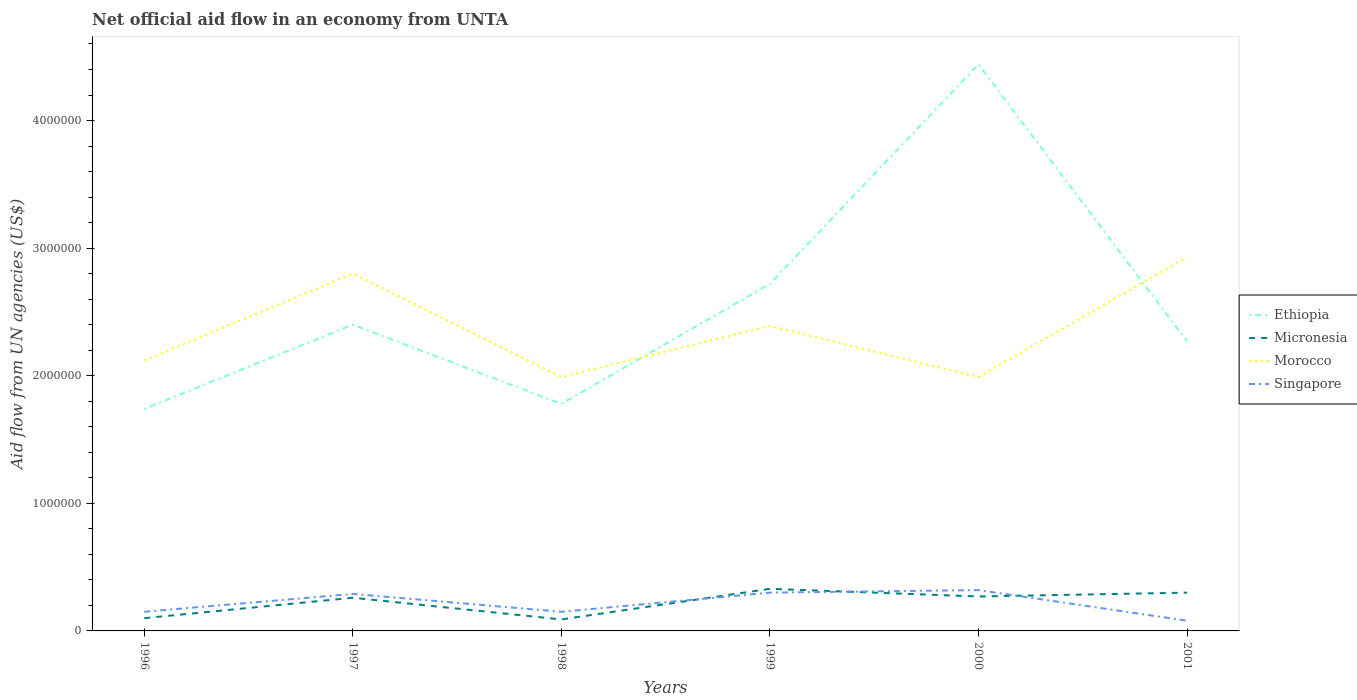How many different coloured lines are there?
Ensure brevity in your answer.  4. Does the line corresponding to Ethiopia intersect with the line corresponding to Morocco?
Your answer should be very brief. Yes. Is the number of lines equal to the number of legend labels?
Your answer should be very brief. Yes. Across all years, what is the maximum net official aid flow in Ethiopia?
Give a very brief answer. 1.74e+06. In which year was the net official aid flow in Micronesia maximum?
Provide a succinct answer. 1998. What is the difference between the highest and the second highest net official aid flow in Singapore?
Ensure brevity in your answer.  2.40e+05. What is the difference between the highest and the lowest net official aid flow in Singapore?
Your answer should be compact. 3. How many lines are there?
Your answer should be very brief. 4. Are the values on the major ticks of Y-axis written in scientific E-notation?
Provide a succinct answer. No. Does the graph contain any zero values?
Provide a short and direct response. No. Does the graph contain grids?
Make the answer very short. No. Where does the legend appear in the graph?
Your answer should be compact. Center right. How many legend labels are there?
Offer a terse response. 4. What is the title of the graph?
Your answer should be very brief. Net official aid flow in an economy from UNTA. What is the label or title of the Y-axis?
Provide a short and direct response. Aid flow from UN agencies (US$). What is the Aid flow from UN agencies (US$) of Ethiopia in 1996?
Give a very brief answer. 1.74e+06. What is the Aid flow from UN agencies (US$) in Micronesia in 1996?
Provide a succinct answer. 1.00e+05. What is the Aid flow from UN agencies (US$) in Morocco in 1996?
Make the answer very short. 2.12e+06. What is the Aid flow from UN agencies (US$) in Ethiopia in 1997?
Ensure brevity in your answer.  2.40e+06. What is the Aid flow from UN agencies (US$) in Morocco in 1997?
Your response must be concise. 2.80e+06. What is the Aid flow from UN agencies (US$) in Singapore in 1997?
Provide a succinct answer. 2.90e+05. What is the Aid flow from UN agencies (US$) of Ethiopia in 1998?
Give a very brief answer. 1.78e+06. What is the Aid flow from UN agencies (US$) in Micronesia in 1998?
Give a very brief answer. 9.00e+04. What is the Aid flow from UN agencies (US$) of Morocco in 1998?
Your answer should be compact. 1.99e+06. What is the Aid flow from UN agencies (US$) in Ethiopia in 1999?
Make the answer very short. 2.72e+06. What is the Aid flow from UN agencies (US$) of Morocco in 1999?
Keep it short and to the point. 2.39e+06. What is the Aid flow from UN agencies (US$) in Ethiopia in 2000?
Provide a short and direct response. 4.44e+06. What is the Aid flow from UN agencies (US$) in Micronesia in 2000?
Provide a short and direct response. 2.70e+05. What is the Aid flow from UN agencies (US$) of Morocco in 2000?
Offer a terse response. 1.99e+06. What is the Aid flow from UN agencies (US$) of Singapore in 2000?
Your response must be concise. 3.20e+05. What is the Aid flow from UN agencies (US$) of Ethiopia in 2001?
Offer a terse response. 2.27e+06. What is the Aid flow from UN agencies (US$) in Morocco in 2001?
Provide a succinct answer. 2.93e+06. Across all years, what is the maximum Aid flow from UN agencies (US$) in Ethiopia?
Make the answer very short. 4.44e+06. Across all years, what is the maximum Aid flow from UN agencies (US$) in Morocco?
Ensure brevity in your answer.  2.93e+06. Across all years, what is the maximum Aid flow from UN agencies (US$) of Singapore?
Offer a very short reply. 3.20e+05. Across all years, what is the minimum Aid flow from UN agencies (US$) of Ethiopia?
Your answer should be very brief. 1.74e+06. Across all years, what is the minimum Aid flow from UN agencies (US$) in Micronesia?
Provide a short and direct response. 9.00e+04. Across all years, what is the minimum Aid flow from UN agencies (US$) in Morocco?
Offer a terse response. 1.99e+06. What is the total Aid flow from UN agencies (US$) in Ethiopia in the graph?
Offer a very short reply. 1.54e+07. What is the total Aid flow from UN agencies (US$) of Micronesia in the graph?
Keep it short and to the point. 1.35e+06. What is the total Aid flow from UN agencies (US$) of Morocco in the graph?
Give a very brief answer. 1.42e+07. What is the total Aid flow from UN agencies (US$) in Singapore in the graph?
Your answer should be compact. 1.29e+06. What is the difference between the Aid flow from UN agencies (US$) in Ethiopia in 1996 and that in 1997?
Ensure brevity in your answer.  -6.60e+05. What is the difference between the Aid flow from UN agencies (US$) of Micronesia in 1996 and that in 1997?
Give a very brief answer. -1.60e+05. What is the difference between the Aid flow from UN agencies (US$) of Morocco in 1996 and that in 1997?
Offer a very short reply. -6.80e+05. What is the difference between the Aid flow from UN agencies (US$) in Morocco in 1996 and that in 1998?
Your answer should be compact. 1.30e+05. What is the difference between the Aid flow from UN agencies (US$) in Ethiopia in 1996 and that in 1999?
Your answer should be very brief. -9.80e+05. What is the difference between the Aid flow from UN agencies (US$) of Morocco in 1996 and that in 1999?
Keep it short and to the point. -2.70e+05. What is the difference between the Aid flow from UN agencies (US$) in Singapore in 1996 and that in 1999?
Provide a succinct answer. -1.50e+05. What is the difference between the Aid flow from UN agencies (US$) in Ethiopia in 1996 and that in 2000?
Give a very brief answer. -2.70e+06. What is the difference between the Aid flow from UN agencies (US$) in Micronesia in 1996 and that in 2000?
Your response must be concise. -1.70e+05. What is the difference between the Aid flow from UN agencies (US$) in Morocco in 1996 and that in 2000?
Provide a succinct answer. 1.30e+05. What is the difference between the Aid flow from UN agencies (US$) of Ethiopia in 1996 and that in 2001?
Provide a short and direct response. -5.30e+05. What is the difference between the Aid flow from UN agencies (US$) of Micronesia in 1996 and that in 2001?
Ensure brevity in your answer.  -2.00e+05. What is the difference between the Aid flow from UN agencies (US$) of Morocco in 1996 and that in 2001?
Offer a very short reply. -8.10e+05. What is the difference between the Aid flow from UN agencies (US$) in Singapore in 1996 and that in 2001?
Make the answer very short. 7.00e+04. What is the difference between the Aid flow from UN agencies (US$) in Ethiopia in 1997 and that in 1998?
Your answer should be compact. 6.20e+05. What is the difference between the Aid flow from UN agencies (US$) of Morocco in 1997 and that in 1998?
Offer a very short reply. 8.10e+05. What is the difference between the Aid flow from UN agencies (US$) in Ethiopia in 1997 and that in 1999?
Make the answer very short. -3.20e+05. What is the difference between the Aid flow from UN agencies (US$) in Morocco in 1997 and that in 1999?
Your answer should be compact. 4.10e+05. What is the difference between the Aid flow from UN agencies (US$) of Singapore in 1997 and that in 1999?
Keep it short and to the point. -10000. What is the difference between the Aid flow from UN agencies (US$) of Ethiopia in 1997 and that in 2000?
Your answer should be very brief. -2.04e+06. What is the difference between the Aid flow from UN agencies (US$) of Morocco in 1997 and that in 2000?
Give a very brief answer. 8.10e+05. What is the difference between the Aid flow from UN agencies (US$) of Morocco in 1997 and that in 2001?
Provide a succinct answer. -1.30e+05. What is the difference between the Aid flow from UN agencies (US$) of Ethiopia in 1998 and that in 1999?
Keep it short and to the point. -9.40e+05. What is the difference between the Aid flow from UN agencies (US$) of Micronesia in 1998 and that in 1999?
Provide a succinct answer. -2.40e+05. What is the difference between the Aid flow from UN agencies (US$) in Morocco in 1998 and that in 1999?
Make the answer very short. -4.00e+05. What is the difference between the Aid flow from UN agencies (US$) in Singapore in 1998 and that in 1999?
Your answer should be very brief. -1.50e+05. What is the difference between the Aid flow from UN agencies (US$) in Ethiopia in 1998 and that in 2000?
Keep it short and to the point. -2.66e+06. What is the difference between the Aid flow from UN agencies (US$) in Ethiopia in 1998 and that in 2001?
Keep it short and to the point. -4.90e+05. What is the difference between the Aid flow from UN agencies (US$) in Micronesia in 1998 and that in 2001?
Offer a terse response. -2.10e+05. What is the difference between the Aid flow from UN agencies (US$) of Morocco in 1998 and that in 2001?
Provide a succinct answer. -9.40e+05. What is the difference between the Aid flow from UN agencies (US$) of Singapore in 1998 and that in 2001?
Offer a very short reply. 7.00e+04. What is the difference between the Aid flow from UN agencies (US$) in Ethiopia in 1999 and that in 2000?
Offer a very short reply. -1.72e+06. What is the difference between the Aid flow from UN agencies (US$) in Morocco in 1999 and that in 2000?
Provide a short and direct response. 4.00e+05. What is the difference between the Aid flow from UN agencies (US$) in Ethiopia in 1999 and that in 2001?
Your answer should be compact. 4.50e+05. What is the difference between the Aid flow from UN agencies (US$) of Morocco in 1999 and that in 2001?
Offer a very short reply. -5.40e+05. What is the difference between the Aid flow from UN agencies (US$) in Ethiopia in 2000 and that in 2001?
Your response must be concise. 2.17e+06. What is the difference between the Aid flow from UN agencies (US$) in Morocco in 2000 and that in 2001?
Offer a very short reply. -9.40e+05. What is the difference between the Aid flow from UN agencies (US$) of Singapore in 2000 and that in 2001?
Keep it short and to the point. 2.40e+05. What is the difference between the Aid flow from UN agencies (US$) of Ethiopia in 1996 and the Aid flow from UN agencies (US$) of Micronesia in 1997?
Give a very brief answer. 1.48e+06. What is the difference between the Aid flow from UN agencies (US$) of Ethiopia in 1996 and the Aid flow from UN agencies (US$) of Morocco in 1997?
Your response must be concise. -1.06e+06. What is the difference between the Aid flow from UN agencies (US$) in Ethiopia in 1996 and the Aid flow from UN agencies (US$) in Singapore in 1997?
Offer a terse response. 1.45e+06. What is the difference between the Aid flow from UN agencies (US$) in Micronesia in 1996 and the Aid flow from UN agencies (US$) in Morocco in 1997?
Keep it short and to the point. -2.70e+06. What is the difference between the Aid flow from UN agencies (US$) in Micronesia in 1996 and the Aid flow from UN agencies (US$) in Singapore in 1997?
Provide a succinct answer. -1.90e+05. What is the difference between the Aid flow from UN agencies (US$) in Morocco in 1996 and the Aid flow from UN agencies (US$) in Singapore in 1997?
Ensure brevity in your answer.  1.83e+06. What is the difference between the Aid flow from UN agencies (US$) in Ethiopia in 1996 and the Aid flow from UN agencies (US$) in Micronesia in 1998?
Give a very brief answer. 1.65e+06. What is the difference between the Aid flow from UN agencies (US$) in Ethiopia in 1996 and the Aid flow from UN agencies (US$) in Singapore in 1998?
Keep it short and to the point. 1.59e+06. What is the difference between the Aid flow from UN agencies (US$) of Micronesia in 1996 and the Aid flow from UN agencies (US$) of Morocco in 1998?
Provide a succinct answer. -1.89e+06. What is the difference between the Aid flow from UN agencies (US$) in Morocco in 1996 and the Aid flow from UN agencies (US$) in Singapore in 1998?
Provide a short and direct response. 1.97e+06. What is the difference between the Aid flow from UN agencies (US$) of Ethiopia in 1996 and the Aid flow from UN agencies (US$) of Micronesia in 1999?
Give a very brief answer. 1.41e+06. What is the difference between the Aid flow from UN agencies (US$) in Ethiopia in 1996 and the Aid flow from UN agencies (US$) in Morocco in 1999?
Keep it short and to the point. -6.50e+05. What is the difference between the Aid flow from UN agencies (US$) of Ethiopia in 1996 and the Aid flow from UN agencies (US$) of Singapore in 1999?
Offer a terse response. 1.44e+06. What is the difference between the Aid flow from UN agencies (US$) of Micronesia in 1996 and the Aid flow from UN agencies (US$) of Morocco in 1999?
Give a very brief answer. -2.29e+06. What is the difference between the Aid flow from UN agencies (US$) of Micronesia in 1996 and the Aid flow from UN agencies (US$) of Singapore in 1999?
Keep it short and to the point. -2.00e+05. What is the difference between the Aid flow from UN agencies (US$) of Morocco in 1996 and the Aid flow from UN agencies (US$) of Singapore in 1999?
Keep it short and to the point. 1.82e+06. What is the difference between the Aid flow from UN agencies (US$) of Ethiopia in 1996 and the Aid flow from UN agencies (US$) of Micronesia in 2000?
Your response must be concise. 1.47e+06. What is the difference between the Aid flow from UN agencies (US$) in Ethiopia in 1996 and the Aid flow from UN agencies (US$) in Morocco in 2000?
Offer a very short reply. -2.50e+05. What is the difference between the Aid flow from UN agencies (US$) of Ethiopia in 1996 and the Aid flow from UN agencies (US$) of Singapore in 2000?
Your answer should be very brief. 1.42e+06. What is the difference between the Aid flow from UN agencies (US$) of Micronesia in 1996 and the Aid flow from UN agencies (US$) of Morocco in 2000?
Give a very brief answer. -1.89e+06. What is the difference between the Aid flow from UN agencies (US$) in Micronesia in 1996 and the Aid flow from UN agencies (US$) in Singapore in 2000?
Ensure brevity in your answer.  -2.20e+05. What is the difference between the Aid flow from UN agencies (US$) in Morocco in 1996 and the Aid flow from UN agencies (US$) in Singapore in 2000?
Give a very brief answer. 1.80e+06. What is the difference between the Aid flow from UN agencies (US$) of Ethiopia in 1996 and the Aid flow from UN agencies (US$) of Micronesia in 2001?
Offer a very short reply. 1.44e+06. What is the difference between the Aid flow from UN agencies (US$) of Ethiopia in 1996 and the Aid flow from UN agencies (US$) of Morocco in 2001?
Keep it short and to the point. -1.19e+06. What is the difference between the Aid flow from UN agencies (US$) in Ethiopia in 1996 and the Aid flow from UN agencies (US$) in Singapore in 2001?
Offer a terse response. 1.66e+06. What is the difference between the Aid flow from UN agencies (US$) in Micronesia in 1996 and the Aid flow from UN agencies (US$) in Morocco in 2001?
Your answer should be very brief. -2.83e+06. What is the difference between the Aid flow from UN agencies (US$) in Morocco in 1996 and the Aid flow from UN agencies (US$) in Singapore in 2001?
Your response must be concise. 2.04e+06. What is the difference between the Aid flow from UN agencies (US$) in Ethiopia in 1997 and the Aid flow from UN agencies (US$) in Micronesia in 1998?
Your answer should be compact. 2.31e+06. What is the difference between the Aid flow from UN agencies (US$) of Ethiopia in 1997 and the Aid flow from UN agencies (US$) of Singapore in 1998?
Keep it short and to the point. 2.25e+06. What is the difference between the Aid flow from UN agencies (US$) of Micronesia in 1997 and the Aid flow from UN agencies (US$) of Morocco in 1998?
Offer a terse response. -1.73e+06. What is the difference between the Aid flow from UN agencies (US$) in Micronesia in 1997 and the Aid flow from UN agencies (US$) in Singapore in 1998?
Your response must be concise. 1.10e+05. What is the difference between the Aid flow from UN agencies (US$) in Morocco in 1997 and the Aid flow from UN agencies (US$) in Singapore in 1998?
Your response must be concise. 2.65e+06. What is the difference between the Aid flow from UN agencies (US$) in Ethiopia in 1997 and the Aid flow from UN agencies (US$) in Micronesia in 1999?
Your response must be concise. 2.07e+06. What is the difference between the Aid flow from UN agencies (US$) in Ethiopia in 1997 and the Aid flow from UN agencies (US$) in Morocco in 1999?
Provide a short and direct response. 10000. What is the difference between the Aid flow from UN agencies (US$) of Ethiopia in 1997 and the Aid flow from UN agencies (US$) of Singapore in 1999?
Give a very brief answer. 2.10e+06. What is the difference between the Aid flow from UN agencies (US$) of Micronesia in 1997 and the Aid flow from UN agencies (US$) of Morocco in 1999?
Offer a very short reply. -2.13e+06. What is the difference between the Aid flow from UN agencies (US$) of Micronesia in 1997 and the Aid flow from UN agencies (US$) of Singapore in 1999?
Provide a short and direct response. -4.00e+04. What is the difference between the Aid flow from UN agencies (US$) of Morocco in 1997 and the Aid flow from UN agencies (US$) of Singapore in 1999?
Keep it short and to the point. 2.50e+06. What is the difference between the Aid flow from UN agencies (US$) in Ethiopia in 1997 and the Aid flow from UN agencies (US$) in Micronesia in 2000?
Offer a very short reply. 2.13e+06. What is the difference between the Aid flow from UN agencies (US$) of Ethiopia in 1997 and the Aid flow from UN agencies (US$) of Singapore in 2000?
Provide a short and direct response. 2.08e+06. What is the difference between the Aid flow from UN agencies (US$) in Micronesia in 1997 and the Aid flow from UN agencies (US$) in Morocco in 2000?
Offer a very short reply. -1.73e+06. What is the difference between the Aid flow from UN agencies (US$) in Morocco in 1997 and the Aid flow from UN agencies (US$) in Singapore in 2000?
Provide a short and direct response. 2.48e+06. What is the difference between the Aid flow from UN agencies (US$) in Ethiopia in 1997 and the Aid flow from UN agencies (US$) in Micronesia in 2001?
Your response must be concise. 2.10e+06. What is the difference between the Aid flow from UN agencies (US$) in Ethiopia in 1997 and the Aid flow from UN agencies (US$) in Morocco in 2001?
Your response must be concise. -5.30e+05. What is the difference between the Aid flow from UN agencies (US$) in Ethiopia in 1997 and the Aid flow from UN agencies (US$) in Singapore in 2001?
Your answer should be compact. 2.32e+06. What is the difference between the Aid flow from UN agencies (US$) of Micronesia in 1997 and the Aid flow from UN agencies (US$) of Morocco in 2001?
Keep it short and to the point. -2.67e+06. What is the difference between the Aid flow from UN agencies (US$) of Micronesia in 1997 and the Aid flow from UN agencies (US$) of Singapore in 2001?
Your answer should be compact. 1.80e+05. What is the difference between the Aid flow from UN agencies (US$) of Morocco in 1997 and the Aid flow from UN agencies (US$) of Singapore in 2001?
Your response must be concise. 2.72e+06. What is the difference between the Aid flow from UN agencies (US$) of Ethiopia in 1998 and the Aid flow from UN agencies (US$) of Micronesia in 1999?
Provide a short and direct response. 1.45e+06. What is the difference between the Aid flow from UN agencies (US$) of Ethiopia in 1998 and the Aid flow from UN agencies (US$) of Morocco in 1999?
Ensure brevity in your answer.  -6.10e+05. What is the difference between the Aid flow from UN agencies (US$) in Ethiopia in 1998 and the Aid flow from UN agencies (US$) in Singapore in 1999?
Provide a succinct answer. 1.48e+06. What is the difference between the Aid flow from UN agencies (US$) of Micronesia in 1998 and the Aid flow from UN agencies (US$) of Morocco in 1999?
Offer a very short reply. -2.30e+06. What is the difference between the Aid flow from UN agencies (US$) in Morocco in 1998 and the Aid flow from UN agencies (US$) in Singapore in 1999?
Your answer should be very brief. 1.69e+06. What is the difference between the Aid flow from UN agencies (US$) of Ethiopia in 1998 and the Aid flow from UN agencies (US$) of Micronesia in 2000?
Give a very brief answer. 1.51e+06. What is the difference between the Aid flow from UN agencies (US$) in Ethiopia in 1998 and the Aid flow from UN agencies (US$) in Singapore in 2000?
Offer a terse response. 1.46e+06. What is the difference between the Aid flow from UN agencies (US$) of Micronesia in 1998 and the Aid flow from UN agencies (US$) of Morocco in 2000?
Your response must be concise. -1.90e+06. What is the difference between the Aid flow from UN agencies (US$) of Micronesia in 1998 and the Aid flow from UN agencies (US$) of Singapore in 2000?
Offer a very short reply. -2.30e+05. What is the difference between the Aid flow from UN agencies (US$) of Morocco in 1998 and the Aid flow from UN agencies (US$) of Singapore in 2000?
Ensure brevity in your answer.  1.67e+06. What is the difference between the Aid flow from UN agencies (US$) in Ethiopia in 1998 and the Aid flow from UN agencies (US$) in Micronesia in 2001?
Offer a very short reply. 1.48e+06. What is the difference between the Aid flow from UN agencies (US$) in Ethiopia in 1998 and the Aid flow from UN agencies (US$) in Morocco in 2001?
Give a very brief answer. -1.15e+06. What is the difference between the Aid flow from UN agencies (US$) of Ethiopia in 1998 and the Aid flow from UN agencies (US$) of Singapore in 2001?
Give a very brief answer. 1.70e+06. What is the difference between the Aid flow from UN agencies (US$) in Micronesia in 1998 and the Aid flow from UN agencies (US$) in Morocco in 2001?
Your answer should be very brief. -2.84e+06. What is the difference between the Aid flow from UN agencies (US$) of Morocco in 1998 and the Aid flow from UN agencies (US$) of Singapore in 2001?
Offer a terse response. 1.91e+06. What is the difference between the Aid flow from UN agencies (US$) in Ethiopia in 1999 and the Aid flow from UN agencies (US$) in Micronesia in 2000?
Keep it short and to the point. 2.45e+06. What is the difference between the Aid flow from UN agencies (US$) in Ethiopia in 1999 and the Aid flow from UN agencies (US$) in Morocco in 2000?
Your answer should be very brief. 7.30e+05. What is the difference between the Aid flow from UN agencies (US$) in Ethiopia in 1999 and the Aid flow from UN agencies (US$) in Singapore in 2000?
Your answer should be very brief. 2.40e+06. What is the difference between the Aid flow from UN agencies (US$) in Micronesia in 1999 and the Aid flow from UN agencies (US$) in Morocco in 2000?
Your answer should be compact. -1.66e+06. What is the difference between the Aid flow from UN agencies (US$) in Micronesia in 1999 and the Aid flow from UN agencies (US$) in Singapore in 2000?
Ensure brevity in your answer.  10000. What is the difference between the Aid flow from UN agencies (US$) in Morocco in 1999 and the Aid flow from UN agencies (US$) in Singapore in 2000?
Your answer should be compact. 2.07e+06. What is the difference between the Aid flow from UN agencies (US$) of Ethiopia in 1999 and the Aid flow from UN agencies (US$) of Micronesia in 2001?
Keep it short and to the point. 2.42e+06. What is the difference between the Aid flow from UN agencies (US$) of Ethiopia in 1999 and the Aid flow from UN agencies (US$) of Singapore in 2001?
Ensure brevity in your answer.  2.64e+06. What is the difference between the Aid flow from UN agencies (US$) of Micronesia in 1999 and the Aid flow from UN agencies (US$) of Morocco in 2001?
Offer a very short reply. -2.60e+06. What is the difference between the Aid flow from UN agencies (US$) in Morocco in 1999 and the Aid flow from UN agencies (US$) in Singapore in 2001?
Keep it short and to the point. 2.31e+06. What is the difference between the Aid flow from UN agencies (US$) in Ethiopia in 2000 and the Aid flow from UN agencies (US$) in Micronesia in 2001?
Ensure brevity in your answer.  4.14e+06. What is the difference between the Aid flow from UN agencies (US$) in Ethiopia in 2000 and the Aid flow from UN agencies (US$) in Morocco in 2001?
Provide a short and direct response. 1.51e+06. What is the difference between the Aid flow from UN agencies (US$) of Ethiopia in 2000 and the Aid flow from UN agencies (US$) of Singapore in 2001?
Offer a very short reply. 4.36e+06. What is the difference between the Aid flow from UN agencies (US$) in Micronesia in 2000 and the Aid flow from UN agencies (US$) in Morocco in 2001?
Provide a succinct answer. -2.66e+06. What is the difference between the Aid flow from UN agencies (US$) in Micronesia in 2000 and the Aid flow from UN agencies (US$) in Singapore in 2001?
Provide a succinct answer. 1.90e+05. What is the difference between the Aid flow from UN agencies (US$) in Morocco in 2000 and the Aid flow from UN agencies (US$) in Singapore in 2001?
Provide a succinct answer. 1.91e+06. What is the average Aid flow from UN agencies (US$) of Ethiopia per year?
Your answer should be compact. 2.56e+06. What is the average Aid flow from UN agencies (US$) of Micronesia per year?
Make the answer very short. 2.25e+05. What is the average Aid flow from UN agencies (US$) of Morocco per year?
Your answer should be compact. 2.37e+06. What is the average Aid flow from UN agencies (US$) of Singapore per year?
Keep it short and to the point. 2.15e+05. In the year 1996, what is the difference between the Aid flow from UN agencies (US$) of Ethiopia and Aid flow from UN agencies (US$) of Micronesia?
Provide a short and direct response. 1.64e+06. In the year 1996, what is the difference between the Aid flow from UN agencies (US$) of Ethiopia and Aid flow from UN agencies (US$) of Morocco?
Offer a very short reply. -3.80e+05. In the year 1996, what is the difference between the Aid flow from UN agencies (US$) in Ethiopia and Aid flow from UN agencies (US$) in Singapore?
Ensure brevity in your answer.  1.59e+06. In the year 1996, what is the difference between the Aid flow from UN agencies (US$) in Micronesia and Aid flow from UN agencies (US$) in Morocco?
Provide a short and direct response. -2.02e+06. In the year 1996, what is the difference between the Aid flow from UN agencies (US$) in Morocco and Aid flow from UN agencies (US$) in Singapore?
Your answer should be compact. 1.97e+06. In the year 1997, what is the difference between the Aid flow from UN agencies (US$) of Ethiopia and Aid flow from UN agencies (US$) of Micronesia?
Provide a short and direct response. 2.14e+06. In the year 1997, what is the difference between the Aid flow from UN agencies (US$) of Ethiopia and Aid flow from UN agencies (US$) of Morocco?
Make the answer very short. -4.00e+05. In the year 1997, what is the difference between the Aid flow from UN agencies (US$) in Ethiopia and Aid flow from UN agencies (US$) in Singapore?
Give a very brief answer. 2.11e+06. In the year 1997, what is the difference between the Aid flow from UN agencies (US$) in Micronesia and Aid flow from UN agencies (US$) in Morocco?
Keep it short and to the point. -2.54e+06. In the year 1997, what is the difference between the Aid flow from UN agencies (US$) of Morocco and Aid flow from UN agencies (US$) of Singapore?
Provide a short and direct response. 2.51e+06. In the year 1998, what is the difference between the Aid flow from UN agencies (US$) of Ethiopia and Aid flow from UN agencies (US$) of Micronesia?
Ensure brevity in your answer.  1.69e+06. In the year 1998, what is the difference between the Aid flow from UN agencies (US$) in Ethiopia and Aid flow from UN agencies (US$) in Morocco?
Provide a succinct answer. -2.10e+05. In the year 1998, what is the difference between the Aid flow from UN agencies (US$) of Ethiopia and Aid flow from UN agencies (US$) of Singapore?
Your answer should be compact. 1.63e+06. In the year 1998, what is the difference between the Aid flow from UN agencies (US$) of Micronesia and Aid flow from UN agencies (US$) of Morocco?
Offer a terse response. -1.90e+06. In the year 1998, what is the difference between the Aid flow from UN agencies (US$) in Morocco and Aid flow from UN agencies (US$) in Singapore?
Ensure brevity in your answer.  1.84e+06. In the year 1999, what is the difference between the Aid flow from UN agencies (US$) in Ethiopia and Aid flow from UN agencies (US$) in Micronesia?
Make the answer very short. 2.39e+06. In the year 1999, what is the difference between the Aid flow from UN agencies (US$) in Ethiopia and Aid flow from UN agencies (US$) in Singapore?
Provide a succinct answer. 2.42e+06. In the year 1999, what is the difference between the Aid flow from UN agencies (US$) in Micronesia and Aid flow from UN agencies (US$) in Morocco?
Keep it short and to the point. -2.06e+06. In the year 1999, what is the difference between the Aid flow from UN agencies (US$) in Micronesia and Aid flow from UN agencies (US$) in Singapore?
Offer a terse response. 3.00e+04. In the year 1999, what is the difference between the Aid flow from UN agencies (US$) in Morocco and Aid flow from UN agencies (US$) in Singapore?
Your answer should be compact. 2.09e+06. In the year 2000, what is the difference between the Aid flow from UN agencies (US$) of Ethiopia and Aid flow from UN agencies (US$) of Micronesia?
Offer a terse response. 4.17e+06. In the year 2000, what is the difference between the Aid flow from UN agencies (US$) in Ethiopia and Aid flow from UN agencies (US$) in Morocco?
Your answer should be compact. 2.45e+06. In the year 2000, what is the difference between the Aid flow from UN agencies (US$) in Ethiopia and Aid flow from UN agencies (US$) in Singapore?
Keep it short and to the point. 4.12e+06. In the year 2000, what is the difference between the Aid flow from UN agencies (US$) of Micronesia and Aid flow from UN agencies (US$) of Morocco?
Your answer should be compact. -1.72e+06. In the year 2000, what is the difference between the Aid flow from UN agencies (US$) of Morocco and Aid flow from UN agencies (US$) of Singapore?
Your answer should be compact. 1.67e+06. In the year 2001, what is the difference between the Aid flow from UN agencies (US$) of Ethiopia and Aid flow from UN agencies (US$) of Micronesia?
Keep it short and to the point. 1.97e+06. In the year 2001, what is the difference between the Aid flow from UN agencies (US$) of Ethiopia and Aid flow from UN agencies (US$) of Morocco?
Offer a terse response. -6.60e+05. In the year 2001, what is the difference between the Aid flow from UN agencies (US$) in Ethiopia and Aid flow from UN agencies (US$) in Singapore?
Offer a terse response. 2.19e+06. In the year 2001, what is the difference between the Aid flow from UN agencies (US$) in Micronesia and Aid flow from UN agencies (US$) in Morocco?
Your answer should be very brief. -2.63e+06. In the year 2001, what is the difference between the Aid flow from UN agencies (US$) of Micronesia and Aid flow from UN agencies (US$) of Singapore?
Offer a very short reply. 2.20e+05. In the year 2001, what is the difference between the Aid flow from UN agencies (US$) in Morocco and Aid flow from UN agencies (US$) in Singapore?
Keep it short and to the point. 2.85e+06. What is the ratio of the Aid flow from UN agencies (US$) in Ethiopia in 1996 to that in 1997?
Your response must be concise. 0.72. What is the ratio of the Aid flow from UN agencies (US$) in Micronesia in 1996 to that in 1997?
Give a very brief answer. 0.38. What is the ratio of the Aid flow from UN agencies (US$) in Morocco in 1996 to that in 1997?
Your answer should be compact. 0.76. What is the ratio of the Aid flow from UN agencies (US$) in Singapore in 1996 to that in 1997?
Give a very brief answer. 0.52. What is the ratio of the Aid flow from UN agencies (US$) in Ethiopia in 1996 to that in 1998?
Ensure brevity in your answer.  0.98. What is the ratio of the Aid flow from UN agencies (US$) of Morocco in 1996 to that in 1998?
Your answer should be compact. 1.07. What is the ratio of the Aid flow from UN agencies (US$) of Singapore in 1996 to that in 1998?
Your answer should be compact. 1. What is the ratio of the Aid flow from UN agencies (US$) in Ethiopia in 1996 to that in 1999?
Your answer should be very brief. 0.64. What is the ratio of the Aid flow from UN agencies (US$) in Micronesia in 1996 to that in 1999?
Your response must be concise. 0.3. What is the ratio of the Aid flow from UN agencies (US$) of Morocco in 1996 to that in 1999?
Ensure brevity in your answer.  0.89. What is the ratio of the Aid flow from UN agencies (US$) in Ethiopia in 1996 to that in 2000?
Your response must be concise. 0.39. What is the ratio of the Aid flow from UN agencies (US$) of Micronesia in 1996 to that in 2000?
Give a very brief answer. 0.37. What is the ratio of the Aid flow from UN agencies (US$) in Morocco in 1996 to that in 2000?
Give a very brief answer. 1.07. What is the ratio of the Aid flow from UN agencies (US$) of Singapore in 1996 to that in 2000?
Your response must be concise. 0.47. What is the ratio of the Aid flow from UN agencies (US$) in Ethiopia in 1996 to that in 2001?
Your answer should be compact. 0.77. What is the ratio of the Aid flow from UN agencies (US$) of Micronesia in 1996 to that in 2001?
Provide a succinct answer. 0.33. What is the ratio of the Aid flow from UN agencies (US$) in Morocco in 1996 to that in 2001?
Provide a short and direct response. 0.72. What is the ratio of the Aid flow from UN agencies (US$) of Singapore in 1996 to that in 2001?
Keep it short and to the point. 1.88. What is the ratio of the Aid flow from UN agencies (US$) of Ethiopia in 1997 to that in 1998?
Provide a short and direct response. 1.35. What is the ratio of the Aid flow from UN agencies (US$) of Micronesia in 1997 to that in 1998?
Your answer should be very brief. 2.89. What is the ratio of the Aid flow from UN agencies (US$) of Morocco in 1997 to that in 1998?
Offer a very short reply. 1.41. What is the ratio of the Aid flow from UN agencies (US$) in Singapore in 1997 to that in 1998?
Keep it short and to the point. 1.93. What is the ratio of the Aid flow from UN agencies (US$) of Ethiopia in 1997 to that in 1999?
Your answer should be compact. 0.88. What is the ratio of the Aid flow from UN agencies (US$) in Micronesia in 1997 to that in 1999?
Offer a very short reply. 0.79. What is the ratio of the Aid flow from UN agencies (US$) of Morocco in 1997 to that in 1999?
Make the answer very short. 1.17. What is the ratio of the Aid flow from UN agencies (US$) in Singapore in 1997 to that in 1999?
Keep it short and to the point. 0.97. What is the ratio of the Aid flow from UN agencies (US$) in Ethiopia in 1997 to that in 2000?
Your answer should be very brief. 0.54. What is the ratio of the Aid flow from UN agencies (US$) in Micronesia in 1997 to that in 2000?
Your answer should be very brief. 0.96. What is the ratio of the Aid flow from UN agencies (US$) in Morocco in 1997 to that in 2000?
Ensure brevity in your answer.  1.41. What is the ratio of the Aid flow from UN agencies (US$) in Singapore in 1997 to that in 2000?
Give a very brief answer. 0.91. What is the ratio of the Aid flow from UN agencies (US$) in Ethiopia in 1997 to that in 2001?
Your response must be concise. 1.06. What is the ratio of the Aid flow from UN agencies (US$) in Micronesia in 1997 to that in 2001?
Provide a succinct answer. 0.87. What is the ratio of the Aid flow from UN agencies (US$) in Morocco in 1997 to that in 2001?
Your answer should be very brief. 0.96. What is the ratio of the Aid flow from UN agencies (US$) of Singapore in 1997 to that in 2001?
Provide a succinct answer. 3.62. What is the ratio of the Aid flow from UN agencies (US$) of Ethiopia in 1998 to that in 1999?
Make the answer very short. 0.65. What is the ratio of the Aid flow from UN agencies (US$) of Micronesia in 1998 to that in 1999?
Your response must be concise. 0.27. What is the ratio of the Aid flow from UN agencies (US$) in Morocco in 1998 to that in 1999?
Your answer should be very brief. 0.83. What is the ratio of the Aid flow from UN agencies (US$) in Ethiopia in 1998 to that in 2000?
Your response must be concise. 0.4. What is the ratio of the Aid flow from UN agencies (US$) in Singapore in 1998 to that in 2000?
Give a very brief answer. 0.47. What is the ratio of the Aid flow from UN agencies (US$) in Ethiopia in 1998 to that in 2001?
Offer a very short reply. 0.78. What is the ratio of the Aid flow from UN agencies (US$) of Micronesia in 1998 to that in 2001?
Your response must be concise. 0.3. What is the ratio of the Aid flow from UN agencies (US$) in Morocco in 1998 to that in 2001?
Offer a terse response. 0.68. What is the ratio of the Aid flow from UN agencies (US$) in Singapore in 1998 to that in 2001?
Ensure brevity in your answer.  1.88. What is the ratio of the Aid flow from UN agencies (US$) in Ethiopia in 1999 to that in 2000?
Offer a terse response. 0.61. What is the ratio of the Aid flow from UN agencies (US$) of Micronesia in 1999 to that in 2000?
Keep it short and to the point. 1.22. What is the ratio of the Aid flow from UN agencies (US$) of Morocco in 1999 to that in 2000?
Provide a succinct answer. 1.2. What is the ratio of the Aid flow from UN agencies (US$) in Ethiopia in 1999 to that in 2001?
Keep it short and to the point. 1.2. What is the ratio of the Aid flow from UN agencies (US$) of Morocco in 1999 to that in 2001?
Offer a terse response. 0.82. What is the ratio of the Aid flow from UN agencies (US$) in Singapore in 1999 to that in 2001?
Your response must be concise. 3.75. What is the ratio of the Aid flow from UN agencies (US$) in Ethiopia in 2000 to that in 2001?
Ensure brevity in your answer.  1.96. What is the ratio of the Aid flow from UN agencies (US$) in Micronesia in 2000 to that in 2001?
Give a very brief answer. 0.9. What is the ratio of the Aid flow from UN agencies (US$) of Morocco in 2000 to that in 2001?
Your response must be concise. 0.68. What is the ratio of the Aid flow from UN agencies (US$) of Singapore in 2000 to that in 2001?
Offer a very short reply. 4. What is the difference between the highest and the second highest Aid flow from UN agencies (US$) of Ethiopia?
Ensure brevity in your answer.  1.72e+06. What is the difference between the highest and the second highest Aid flow from UN agencies (US$) of Singapore?
Keep it short and to the point. 2.00e+04. What is the difference between the highest and the lowest Aid flow from UN agencies (US$) of Ethiopia?
Ensure brevity in your answer.  2.70e+06. What is the difference between the highest and the lowest Aid flow from UN agencies (US$) of Morocco?
Your answer should be very brief. 9.40e+05. 